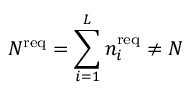<formula> <loc_0><loc_0><loc_500><loc_500>{ N ^ { r e q } = \sum _ { i = 1 } ^ { L } n _ { i } ^ { r e q } \not = N }</formula> 